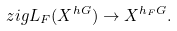Convert formula to latex. <formula><loc_0><loc_0><loc_500><loc_500>\ z i g L _ { F } ( X ^ { h G } ) \rightarrow X ^ { h _ { F } G } .</formula> 